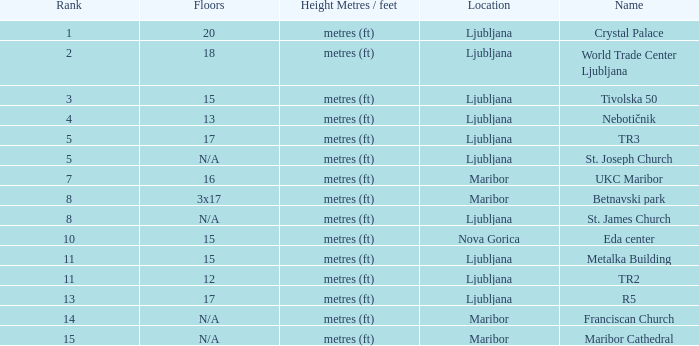I'm looking to parse the entire table for insights. Could you assist me with that? {'header': ['Rank', 'Floors', 'Height Metres / feet', 'Location', 'Name'], 'rows': [['1', '20', 'metres (ft)', 'Ljubljana', 'Crystal Palace'], ['2', '18', 'metres (ft)', 'Ljubljana', 'World Trade Center Ljubljana'], ['3', '15', 'metres (ft)', 'Ljubljana', 'Tivolska 50'], ['4', '13', 'metres (ft)', 'Ljubljana', 'Nebotičnik'], ['5', '17', 'metres (ft)', 'Ljubljana', 'TR3'], ['5', 'N/A', 'metres (ft)', 'Ljubljana', 'St. Joseph Church'], ['7', '16', 'metres (ft)', 'Maribor', 'UKC Maribor'], ['8', '3x17', 'metres (ft)', 'Maribor', 'Betnavski park'], ['8', 'N/A', 'metres (ft)', 'Ljubljana', 'St. James Church'], ['10', '15', 'metres (ft)', 'Nova Gorica', 'Eda center'], ['11', '15', 'metres (ft)', 'Ljubljana', 'Metalka Building'], ['11', '12', 'metres (ft)', 'Ljubljana', 'TR2'], ['13', '17', 'metres (ft)', 'Ljubljana', 'R5'], ['14', 'N/A', 'metres (ft)', 'Maribor', 'Franciscan Church'], ['15', 'N/A', 'metres (ft)', 'Maribor', 'Maribor Cathedral']]} Which Height Metres / feet has a Rank of 8, and Floors of 3x17? Metres (ft). 